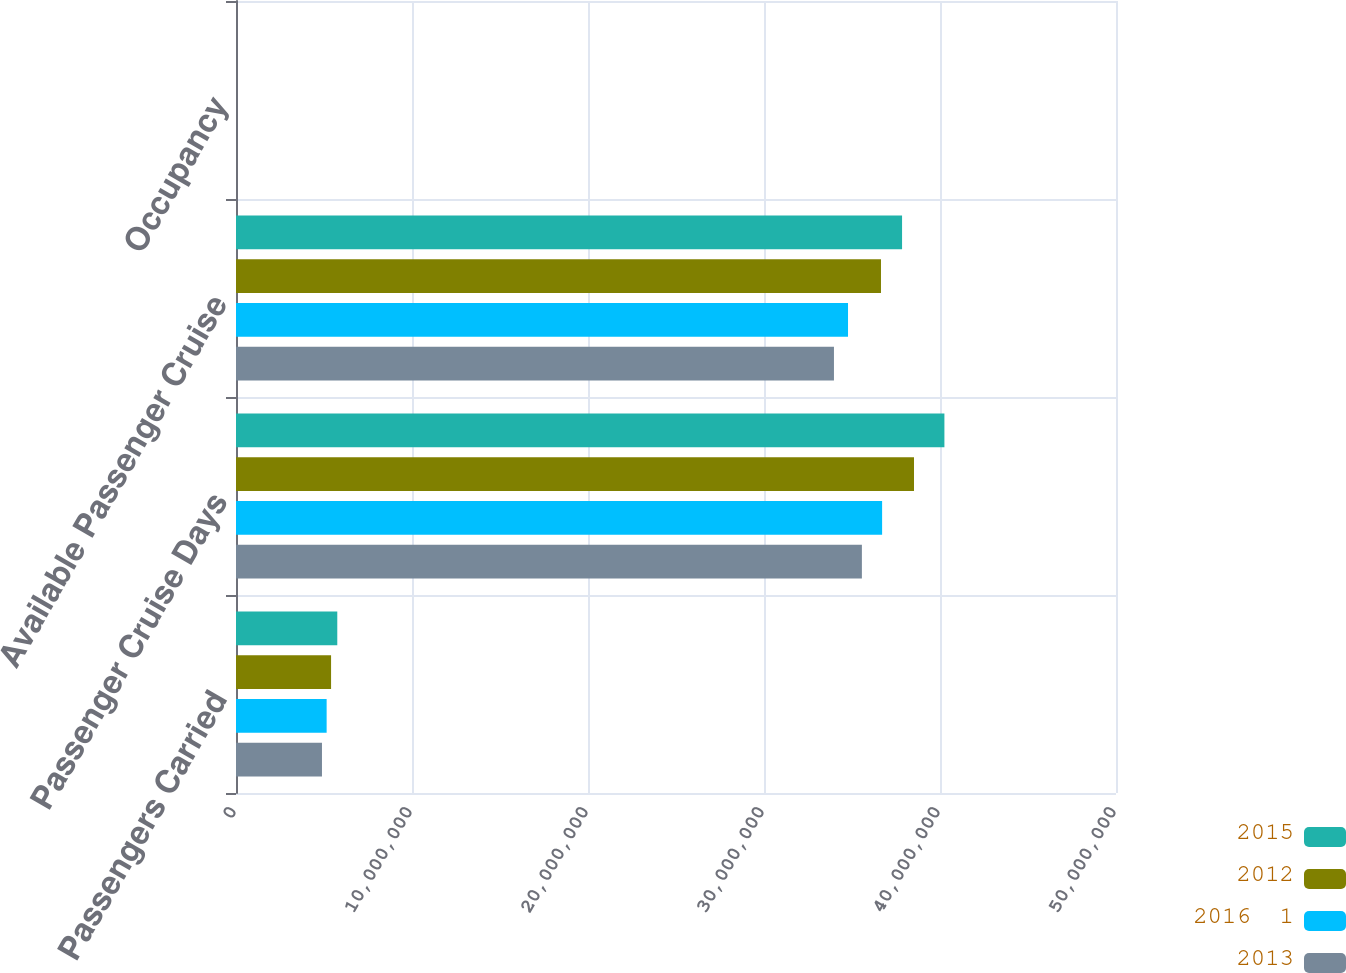<chart> <loc_0><loc_0><loc_500><loc_500><stacked_bar_chart><ecel><fcel>Passengers Carried<fcel>Passenger Cruise Days<fcel>Available Passenger Cruise<fcel>Occupancy<nl><fcel>2015<fcel>5.75475e+06<fcel>4.02506e+07<fcel>3.78446e+07<fcel>106.4<nl><fcel>2012<fcel>5.4019e+06<fcel>3.85231e+07<fcel>3.66466e+07<fcel>105.1<nl><fcel>2016  1<fcel>5.14995e+06<fcel>3.6711e+07<fcel>3.47739e+07<fcel>105.6<nl><fcel>2013<fcel>4.88476e+06<fcel>3.55618e+07<fcel>3.39749e+07<fcel>104.7<nl></chart> 